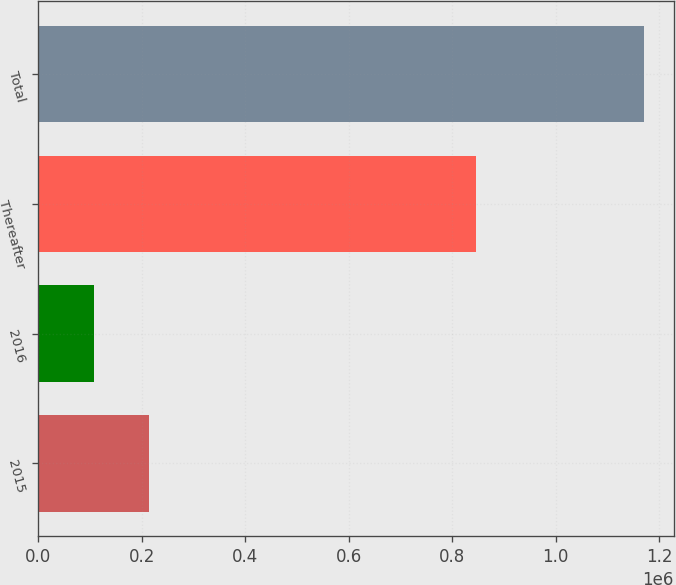<chart> <loc_0><loc_0><loc_500><loc_500><bar_chart><fcel>2015<fcel>2016<fcel>Thereafter<fcel>Total<nl><fcel>213154<fcel>106808<fcel>846873<fcel>1.17027e+06<nl></chart> 